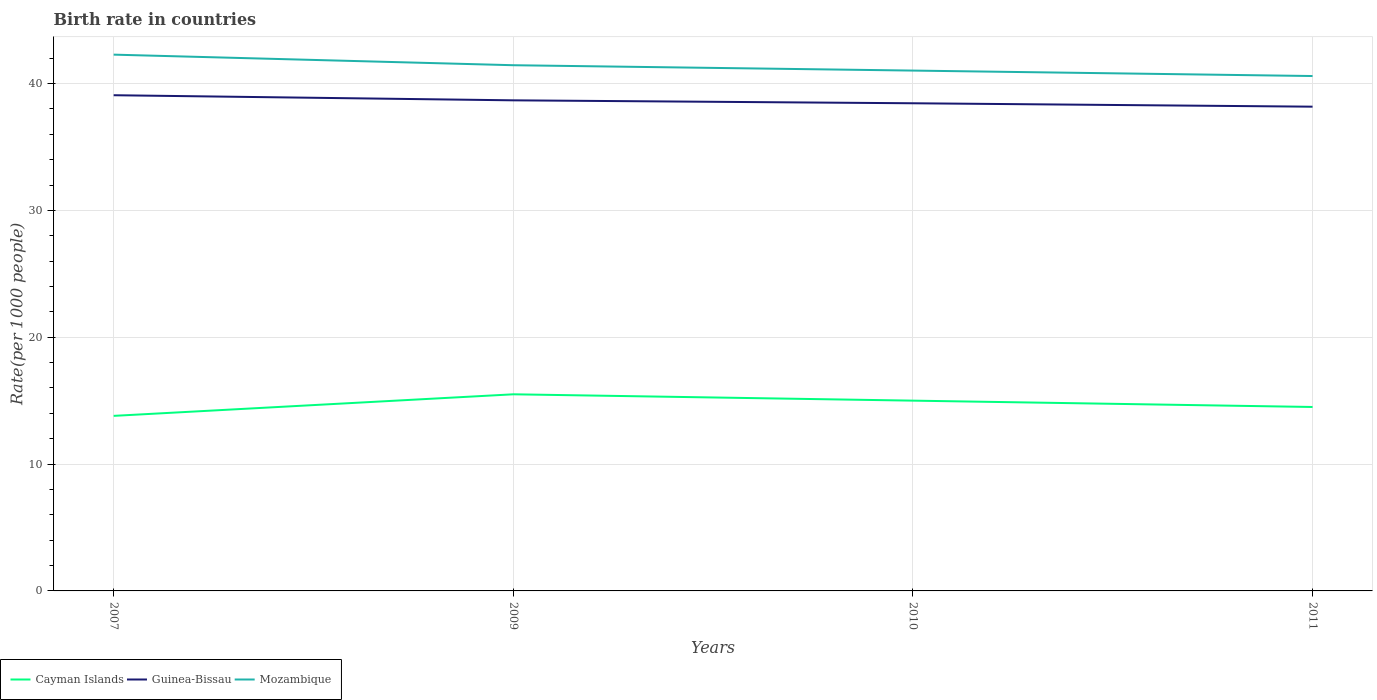How many different coloured lines are there?
Provide a short and direct response. 3. Across all years, what is the maximum birth rate in Guinea-Bissau?
Your response must be concise. 38.17. What is the total birth rate in Mozambique in the graph?
Your response must be concise. 0.43. What is the difference between the highest and the second highest birth rate in Cayman Islands?
Your response must be concise. 1.7. What is the difference between the highest and the lowest birth rate in Mozambique?
Provide a succinct answer. 2. How many legend labels are there?
Offer a terse response. 3. What is the title of the graph?
Your response must be concise. Birth rate in countries. What is the label or title of the Y-axis?
Ensure brevity in your answer.  Rate(per 1000 people). What is the Rate(per 1000 people) of Cayman Islands in 2007?
Your answer should be compact. 13.8. What is the Rate(per 1000 people) of Guinea-Bissau in 2007?
Keep it short and to the point. 39.08. What is the Rate(per 1000 people) of Mozambique in 2007?
Give a very brief answer. 42.28. What is the Rate(per 1000 people) in Cayman Islands in 2009?
Give a very brief answer. 15.5. What is the Rate(per 1000 people) of Guinea-Bissau in 2009?
Keep it short and to the point. 38.67. What is the Rate(per 1000 people) of Mozambique in 2009?
Keep it short and to the point. 41.44. What is the Rate(per 1000 people) in Guinea-Bissau in 2010?
Ensure brevity in your answer.  38.44. What is the Rate(per 1000 people) of Mozambique in 2010?
Your answer should be compact. 41.02. What is the Rate(per 1000 people) of Cayman Islands in 2011?
Offer a very short reply. 14.5. What is the Rate(per 1000 people) of Guinea-Bissau in 2011?
Ensure brevity in your answer.  38.17. What is the Rate(per 1000 people) in Mozambique in 2011?
Your answer should be very brief. 40.59. Across all years, what is the maximum Rate(per 1000 people) in Cayman Islands?
Provide a succinct answer. 15.5. Across all years, what is the maximum Rate(per 1000 people) of Guinea-Bissau?
Ensure brevity in your answer.  39.08. Across all years, what is the maximum Rate(per 1000 people) of Mozambique?
Give a very brief answer. 42.28. Across all years, what is the minimum Rate(per 1000 people) in Guinea-Bissau?
Your answer should be compact. 38.17. Across all years, what is the minimum Rate(per 1000 people) of Mozambique?
Provide a succinct answer. 40.59. What is the total Rate(per 1000 people) of Cayman Islands in the graph?
Your answer should be very brief. 58.8. What is the total Rate(per 1000 people) in Guinea-Bissau in the graph?
Your answer should be compact. 154.37. What is the total Rate(per 1000 people) in Mozambique in the graph?
Keep it short and to the point. 165.33. What is the difference between the Rate(per 1000 people) in Cayman Islands in 2007 and that in 2009?
Your answer should be very brief. -1.7. What is the difference between the Rate(per 1000 people) of Guinea-Bissau in 2007 and that in 2009?
Offer a terse response. 0.4. What is the difference between the Rate(per 1000 people) of Mozambique in 2007 and that in 2009?
Your answer should be very brief. 0.83. What is the difference between the Rate(per 1000 people) in Cayman Islands in 2007 and that in 2010?
Your answer should be compact. -1.2. What is the difference between the Rate(per 1000 people) of Guinea-Bissau in 2007 and that in 2010?
Your response must be concise. 0.63. What is the difference between the Rate(per 1000 people) of Mozambique in 2007 and that in 2010?
Keep it short and to the point. 1.26. What is the difference between the Rate(per 1000 people) of Cayman Islands in 2007 and that in 2011?
Provide a succinct answer. -0.7. What is the difference between the Rate(per 1000 people) of Guinea-Bissau in 2007 and that in 2011?
Your answer should be compact. 0.9. What is the difference between the Rate(per 1000 people) in Mozambique in 2007 and that in 2011?
Provide a short and direct response. 1.69. What is the difference between the Rate(per 1000 people) in Guinea-Bissau in 2009 and that in 2010?
Offer a terse response. 0.23. What is the difference between the Rate(per 1000 people) in Mozambique in 2009 and that in 2010?
Provide a succinct answer. 0.42. What is the difference between the Rate(per 1000 people) in Cayman Islands in 2009 and that in 2011?
Provide a succinct answer. 1. What is the difference between the Rate(per 1000 people) in Guinea-Bissau in 2009 and that in 2011?
Ensure brevity in your answer.  0.5. What is the difference between the Rate(per 1000 people) of Mozambique in 2009 and that in 2011?
Your answer should be compact. 0.85. What is the difference between the Rate(per 1000 people) of Cayman Islands in 2010 and that in 2011?
Your answer should be compact. 0.5. What is the difference between the Rate(per 1000 people) of Guinea-Bissau in 2010 and that in 2011?
Make the answer very short. 0.27. What is the difference between the Rate(per 1000 people) of Mozambique in 2010 and that in 2011?
Ensure brevity in your answer.  0.43. What is the difference between the Rate(per 1000 people) of Cayman Islands in 2007 and the Rate(per 1000 people) of Guinea-Bissau in 2009?
Keep it short and to the point. -24.88. What is the difference between the Rate(per 1000 people) in Cayman Islands in 2007 and the Rate(per 1000 people) in Mozambique in 2009?
Ensure brevity in your answer.  -27.64. What is the difference between the Rate(per 1000 people) in Guinea-Bissau in 2007 and the Rate(per 1000 people) in Mozambique in 2009?
Provide a succinct answer. -2.37. What is the difference between the Rate(per 1000 people) in Cayman Islands in 2007 and the Rate(per 1000 people) in Guinea-Bissau in 2010?
Provide a short and direct response. -24.64. What is the difference between the Rate(per 1000 people) in Cayman Islands in 2007 and the Rate(per 1000 people) in Mozambique in 2010?
Provide a short and direct response. -27.22. What is the difference between the Rate(per 1000 people) in Guinea-Bissau in 2007 and the Rate(per 1000 people) in Mozambique in 2010?
Give a very brief answer. -1.94. What is the difference between the Rate(per 1000 people) in Cayman Islands in 2007 and the Rate(per 1000 people) in Guinea-Bissau in 2011?
Provide a succinct answer. -24.38. What is the difference between the Rate(per 1000 people) of Cayman Islands in 2007 and the Rate(per 1000 people) of Mozambique in 2011?
Make the answer very short. -26.79. What is the difference between the Rate(per 1000 people) in Guinea-Bissau in 2007 and the Rate(per 1000 people) in Mozambique in 2011?
Keep it short and to the point. -1.51. What is the difference between the Rate(per 1000 people) of Cayman Islands in 2009 and the Rate(per 1000 people) of Guinea-Bissau in 2010?
Your answer should be very brief. -22.94. What is the difference between the Rate(per 1000 people) in Cayman Islands in 2009 and the Rate(per 1000 people) in Mozambique in 2010?
Your answer should be compact. -25.52. What is the difference between the Rate(per 1000 people) in Guinea-Bissau in 2009 and the Rate(per 1000 people) in Mozambique in 2010?
Your answer should be compact. -2.35. What is the difference between the Rate(per 1000 people) in Cayman Islands in 2009 and the Rate(per 1000 people) in Guinea-Bissau in 2011?
Give a very brief answer. -22.68. What is the difference between the Rate(per 1000 people) in Cayman Islands in 2009 and the Rate(per 1000 people) in Mozambique in 2011?
Keep it short and to the point. -25.09. What is the difference between the Rate(per 1000 people) of Guinea-Bissau in 2009 and the Rate(per 1000 people) of Mozambique in 2011?
Your response must be concise. -1.92. What is the difference between the Rate(per 1000 people) in Cayman Islands in 2010 and the Rate(per 1000 people) in Guinea-Bissau in 2011?
Give a very brief answer. -23.18. What is the difference between the Rate(per 1000 people) of Cayman Islands in 2010 and the Rate(per 1000 people) of Mozambique in 2011?
Provide a short and direct response. -25.59. What is the difference between the Rate(per 1000 people) in Guinea-Bissau in 2010 and the Rate(per 1000 people) in Mozambique in 2011?
Keep it short and to the point. -2.15. What is the average Rate(per 1000 people) of Guinea-Bissau per year?
Offer a very short reply. 38.59. What is the average Rate(per 1000 people) in Mozambique per year?
Your answer should be very brief. 41.33. In the year 2007, what is the difference between the Rate(per 1000 people) of Cayman Islands and Rate(per 1000 people) of Guinea-Bissau?
Ensure brevity in your answer.  -25.28. In the year 2007, what is the difference between the Rate(per 1000 people) in Cayman Islands and Rate(per 1000 people) in Mozambique?
Ensure brevity in your answer.  -28.48. In the year 2007, what is the difference between the Rate(per 1000 people) of Guinea-Bissau and Rate(per 1000 people) of Mozambique?
Your answer should be very brief. -3.2. In the year 2009, what is the difference between the Rate(per 1000 people) in Cayman Islands and Rate(per 1000 people) in Guinea-Bissau?
Give a very brief answer. -23.18. In the year 2009, what is the difference between the Rate(per 1000 people) in Cayman Islands and Rate(per 1000 people) in Mozambique?
Keep it short and to the point. -25.94. In the year 2009, what is the difference between the Rate(per 1000 people) of Guinea-Bissau and Rate(per 1000 people) of Mozambique?
Your answer should be compact. -2.77. In the year 2010, what is the difference between the Rate(per 1000 people) of Cayman Islands and Rate(per 1000 people) of Guinea-Bissau?
Your response must be concise. -23.44. In the year 2010, what is the difference between the Rate(per 1000 people) in Cayman Islands and Rate(per 1000 people) in Mozambique?
Provide a succinct answer. -26.02. In the year 2010, what is the difference between the Rate(per 1000 people) of Guinea-Bissau and Rate(per 1000 people) of Mozambique?
Your answer should be compact. -2.58. In the year 2011, what is the difference between the Rate(per 1000 people) of Cayman Islands and Rate(per 1000 people) of Guinea-Bissau?
Offer a very short reply. -23.68. In the year 2011, what is the difference between the Rate(per 1000 people) of Cayman Islands and Rate(per 1000 people) of Mozambique?
Offer a very short reply. -26.09. In the year 2011, what is the difference between the Rate(per 1000 people) of Guinea-Bissau and Rate(per 1000 people) of Mozambique?
Your answer should be compact. -2.42. What is the ratio of the Rate(per 1000 people) of Cayman Islands in 2007 to that in 2009?
Provide a succinct answer. 0.89. What is the ratio of the Rate(per 1000 people) of Guinea-Bissau in 2007 to that in 2009?
Your answer should be compact. 1.01. What is the ratio of the Rate(per 1000 people) of Mozambique in 2007 to that in 2009?
Your response must be concise. 1.02. What is the ratio of the Rate(per 1000 people) of Cayman Islands in 2007 to that in 2010?
Your answer should be compact. 0.92. What is the ratio of the Rate(per 1000 people) of Guinea-Bissau in 2007 to that in 2010?
Offer a terse response. 1.02. What is the ratio of the Rate(per 1000 people) of Mozambique in 2007 to that in 2010?
Keep it short and to the point. 1.03. What is the ratio of the Rate(per 1000 people) in Cayman Islands in 2007 to that in 2011?
Ensure brevity in your answer.  0.95. What is the ratio of the Rate(per 1000 people) of Guinea-Bissau in 2007 to that in 2011?
Provide a succinct answer. 1.02. What is the ratio of the Rate(per 1000 people) in Mozambique in 2007 to that in 2011?
Your answer should be compact. 1.04. What is the ratio of the Rate(per 1000 people) of Guinea-Bissau in 2009 to that in 2010?
Your answer should be very brief. 1.01. What is the ratio of the Rate(per 1000 people) in Mozambique in 2009 to that in 2010?
Provide a short and direct response. 1.01. What is the ratio of the Rate(per 1000 people) in Cayman Islands in 2009 to that in 2011?
Provide a succinct answer. 1.07. What is the ratio of the Rate(per 1000 people) of Guinea-Bissau in 2009 to that in 2011?
Give a very brief answer. 1.01. What is the ratio of the Rate(per 1000 people) in Mozambique in 2009 to that in 2011?
Your answer should be very brief. 1.02. What is the ratio of the Rate(per 1000 people) of Cayman Islands in 2010 to that in 2011?
Your answer should be very brief. 1.03. What is the ratio of the Rate(per 1000 people) in Guinea-Bissau in 2010 to that in 2011?
Your answer should be compact. 1.01. What is the ratio of the Rate(per 1000 people) in Mozambique in 2010 to that in 2011?
Offer a terse response. 1.01. What is the difference between the highest and the second highest Rate(per 1000 people) in Guinea-Bissau?
Provide a short and direct response. 0.4. What is the difference between the highest and the second highest Rate(per 1000 people) of Mozambique?
Keep it short and to the point. 0.83. What is the difference between the highest and the lowest Rate(per 1000 people) in Guinea-Bissau?
Offer a very short reply. 0.9. What is the difference between the highest and the lowest Rate(per 1000 people) of Mozambique?
Provide a succinct answer. 1.69. 